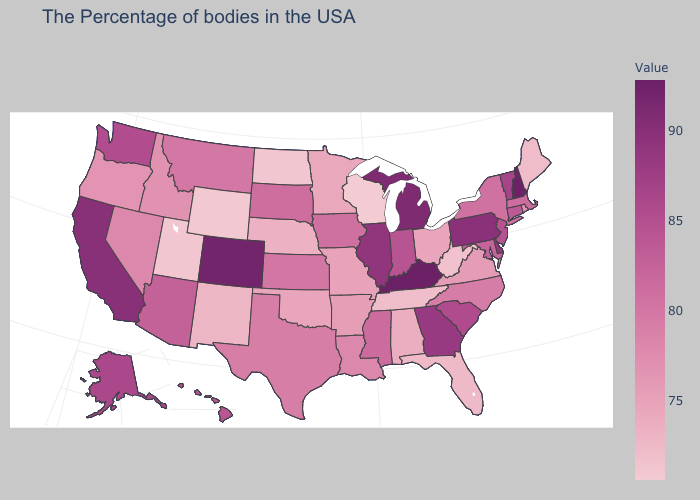Does Maine have a higher value than South Carolina?
Keep it brief. No. Which states have the lowest value in the USA?
Write a very short answer. Wisconsin. Which states have the lowest value in the MidWest?
Quick response, please. Wisconsin. Does the map have missing data?
Concise answer only. No. Does Colorado have a higher value than Utah?
Short answer required. Yes. Among the states that border Arkansas , does Missouri have the lowest value?
Answer briefly. No. 